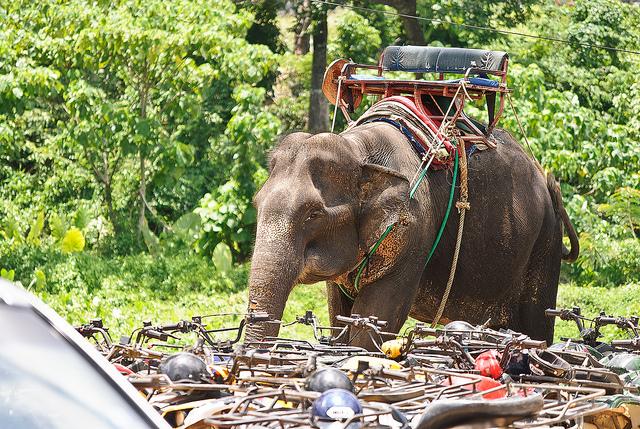Is there a car in the picture?
Answer briefly. Yes. Why is there a pachyderm on top of the elephant?
Quick response, please. There isn't. Is anyone currently riding the pachyderm?
Quick response, please. No. 